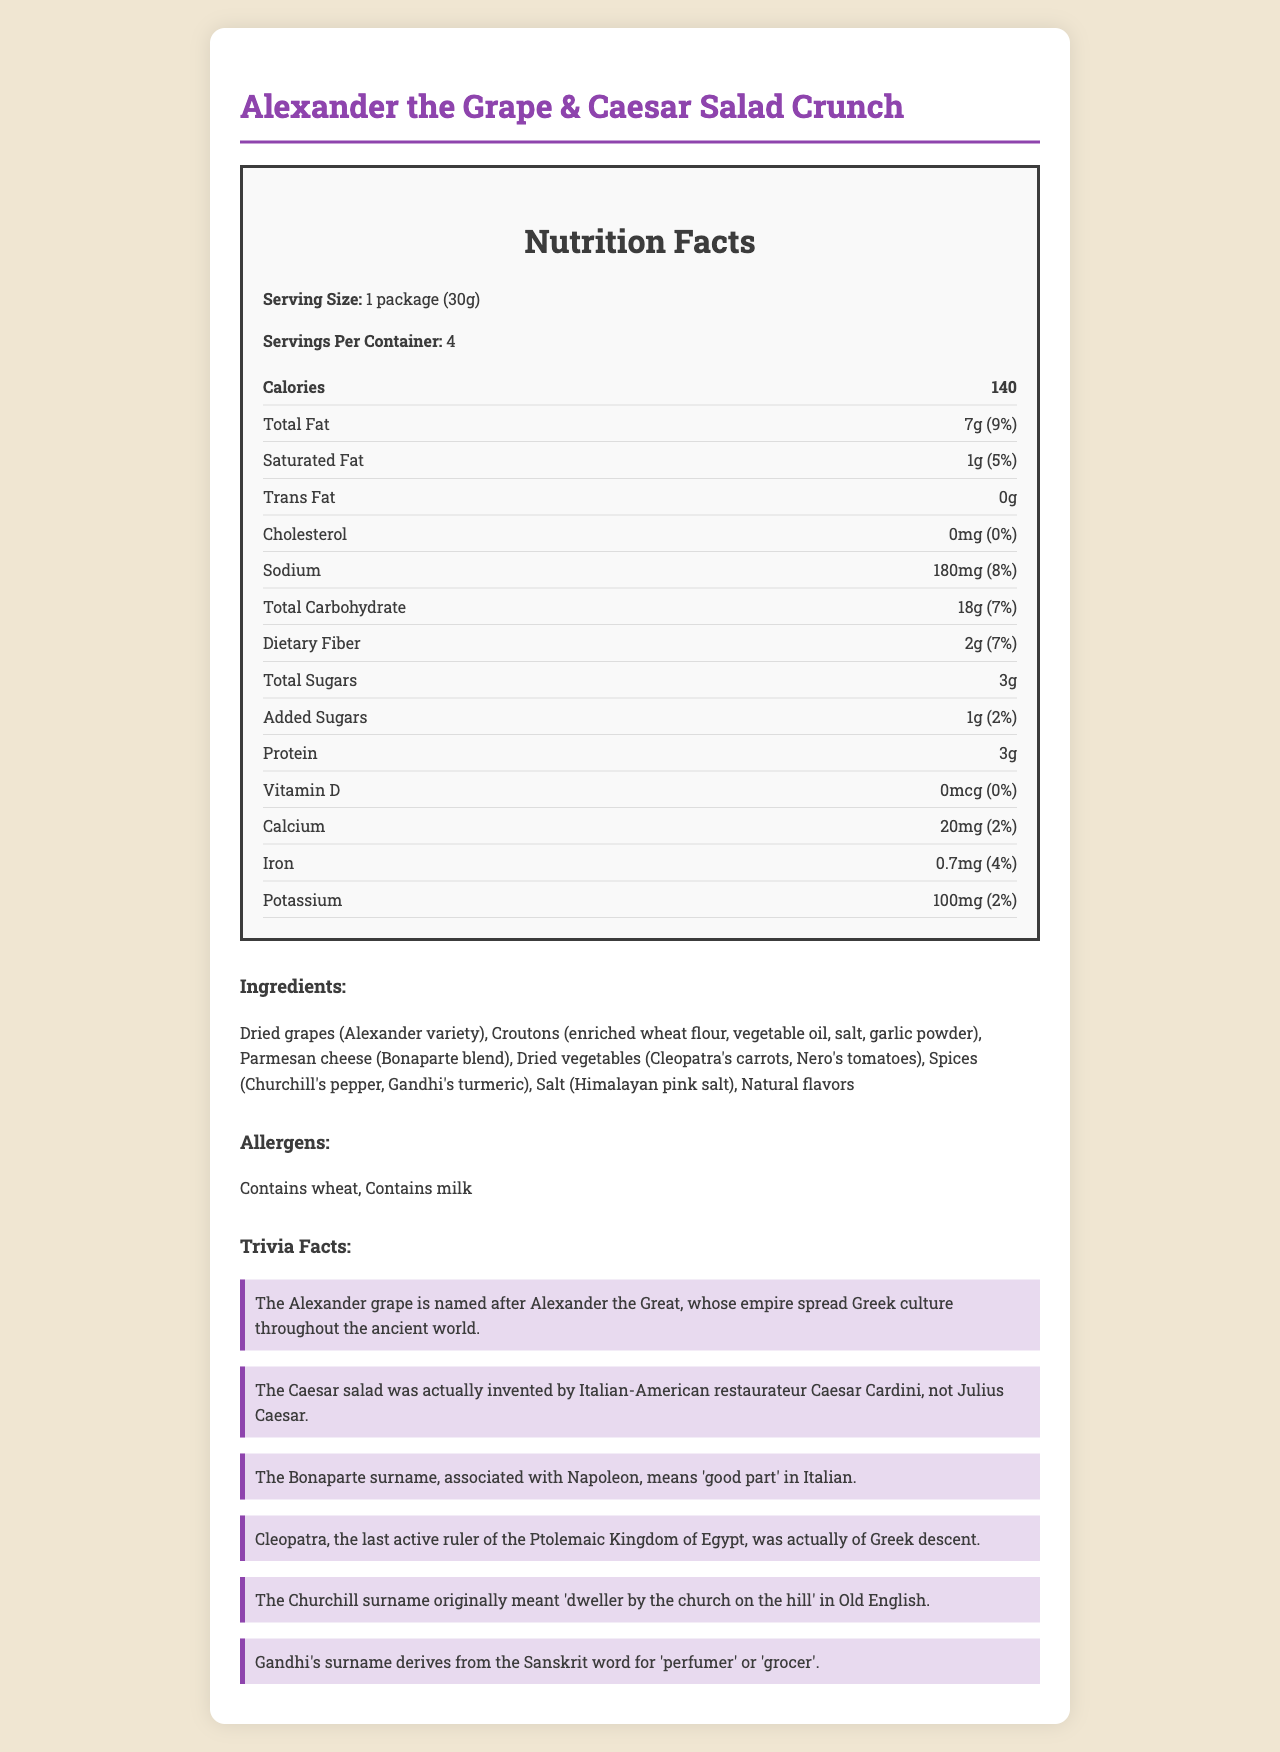what is the serving size? The serving size is specified at the beginning of the nutrition facts section.
Answer: 1 package (30g) how many calories are there per serving? The calorie count is listed in the nutrition facts section.
Answer: 140 what is the total fat content per serving? The total fat content is listed in the nutrition facts section.
Answer: 7g are there any added sugars in this product? The document lists 1g of added sugars.
Answer: Yes how much protein is there per serving? The protein content is specified in the nutrition facts section.
Answer: 3g how many servings are there per container? The number of servings per container is specified at the beginning of the nutrition facts section.
Answer: 4 what is the percentage of the daily value of sodium per serving? The sodium daily value percentage is listed in the nutrition facts section.
Answer: 8% which vitamin or mineral has the highest daily value percentage? A. Vitamin D B. Calcium C. Iron D. Potassium Iron has the highest daily value percentage at 4%.
Answer: C which of the following is an allergen in this product? A. Peanuts B. Wheat C. Soy D. Fish Wheat is listed as an allergen in the allergens section.
Answer: B does this product contain trans fats? The document specifies that there are 0g of trans fats.
Answer: No is the Caesar salad named after Julius Caesar? A trivia fact explains that the Caesar salad was invented by Caesar Cardini, not Julius Caesar.
Answer: No summarize the main idea of the document The document elaborates on the nutrition facts, ingredients, allergens, and trivia regarding the global fusion snack, detailing nutritional content and historical connections of ingredient names.
Answer: The document provides detailed nutrition facts and ingredient information for a global fusion snack named "Alexander the Grape & Caesar Salad Crunch", with nutrients listed per serving, allergen information, and interesting trivia about the origins of the names of various ingredients. who invented the Caesar salad? While the trivia fact states that Caesar Cardini invented the salad, details about him are not included.
Answer: Not enough information 